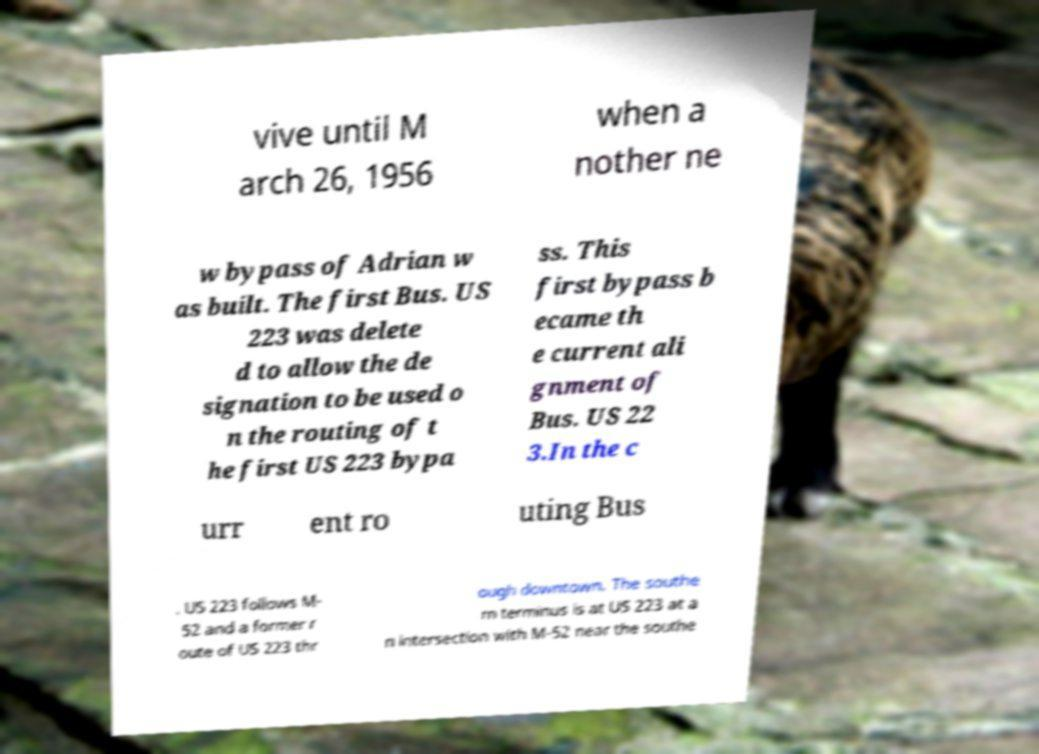Can you accurately transcribe the text from the provided image for me? vive until M arch 26, 1956 when a nother ne w bypass of Adrian w as built. The first Bus. US 223 was delete d to allow the de signation to be used o n the routing of t he first US 223 bypa ss. This first bypass b ecame th e current ali gnment of Bus. US 22 3.In the c urr ent ro uting Bus . US 223 follows M- 52 and a former r oute of US 223 thr ough downtown. The southe rn terminus is at US 223 at a n intersection with M-52 near the southe 